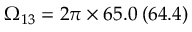<formula> <loc_0><loc_0><loc_500><loc_500>\Omega _ { 1 3 } = 2 \pi \times 6 5 . 0 \, ( 6 4 . 4 )</formula> 